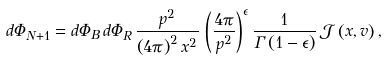Convert formula to latex. <formula><loc_0><loc_0><loc_500><loc_500>d \Phi _ { N + 1 } = d \Phi _ { B } \, d \Phi _ { R } \, \frac { p ^ { 2 } } { \left ( 4 \pi \right ) ^ { 2 } x ^ { 2 } } \, \left ( \frac { 4 \pi } { p ^ { 2 } } \right ) ^ { \epsilon } \frac { 1 } { \Gamma \left ( 1 - \epsilon \right ) } \, \mathcal { J } \left ( x , v \right ) ,</formula> 